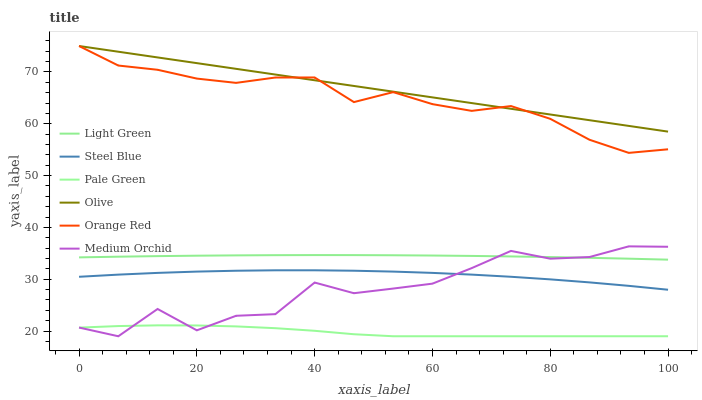Does Pale Green have the minimum area under the curve?
Answer yes or no. Yes. Does Olive have the maximum area under the curve?
Answer yes or no. Yes. Does Steel Blue have the minimum area under the curve?
Answer yes or no. No. Does Steel Blue have the maximum area under the curve?
Answer yes or no. No. Is Olive the smoothest?
Answer yes or no. Yes. Is Medium Orchid the roughest?
Answer yes or no. Yes. Is Steel Blue the smoothest?
Answer yes or no. No. Is Steel Blue the roughest?
Answer yes or no. No. Does Medium Orchid have the lowest value?
Answer yes or no. Yes. Does Steel Blue have the lowest value?
Answer yes or no. No. Does Orange Red have the highest value?
Answer yes or no. Yes. Does Steel Blue have the highest value?
Answer yes or no. No. Is Pale Green less than Olive?
Answer yes or no. Yes. Is Orange Red greater than Medium Orchid?
Answer yes or no. Yes. Does Medium Orchid intersect Light Green?
Answer yes or no. Yes. Is Medium Orchid less than Light Green?
Answer yes or no. No. Is Medium Orchid greater than Light Green?
Answer yes or no. No. Does Pale Green intersect Olive?
Answer yes or no. No. 